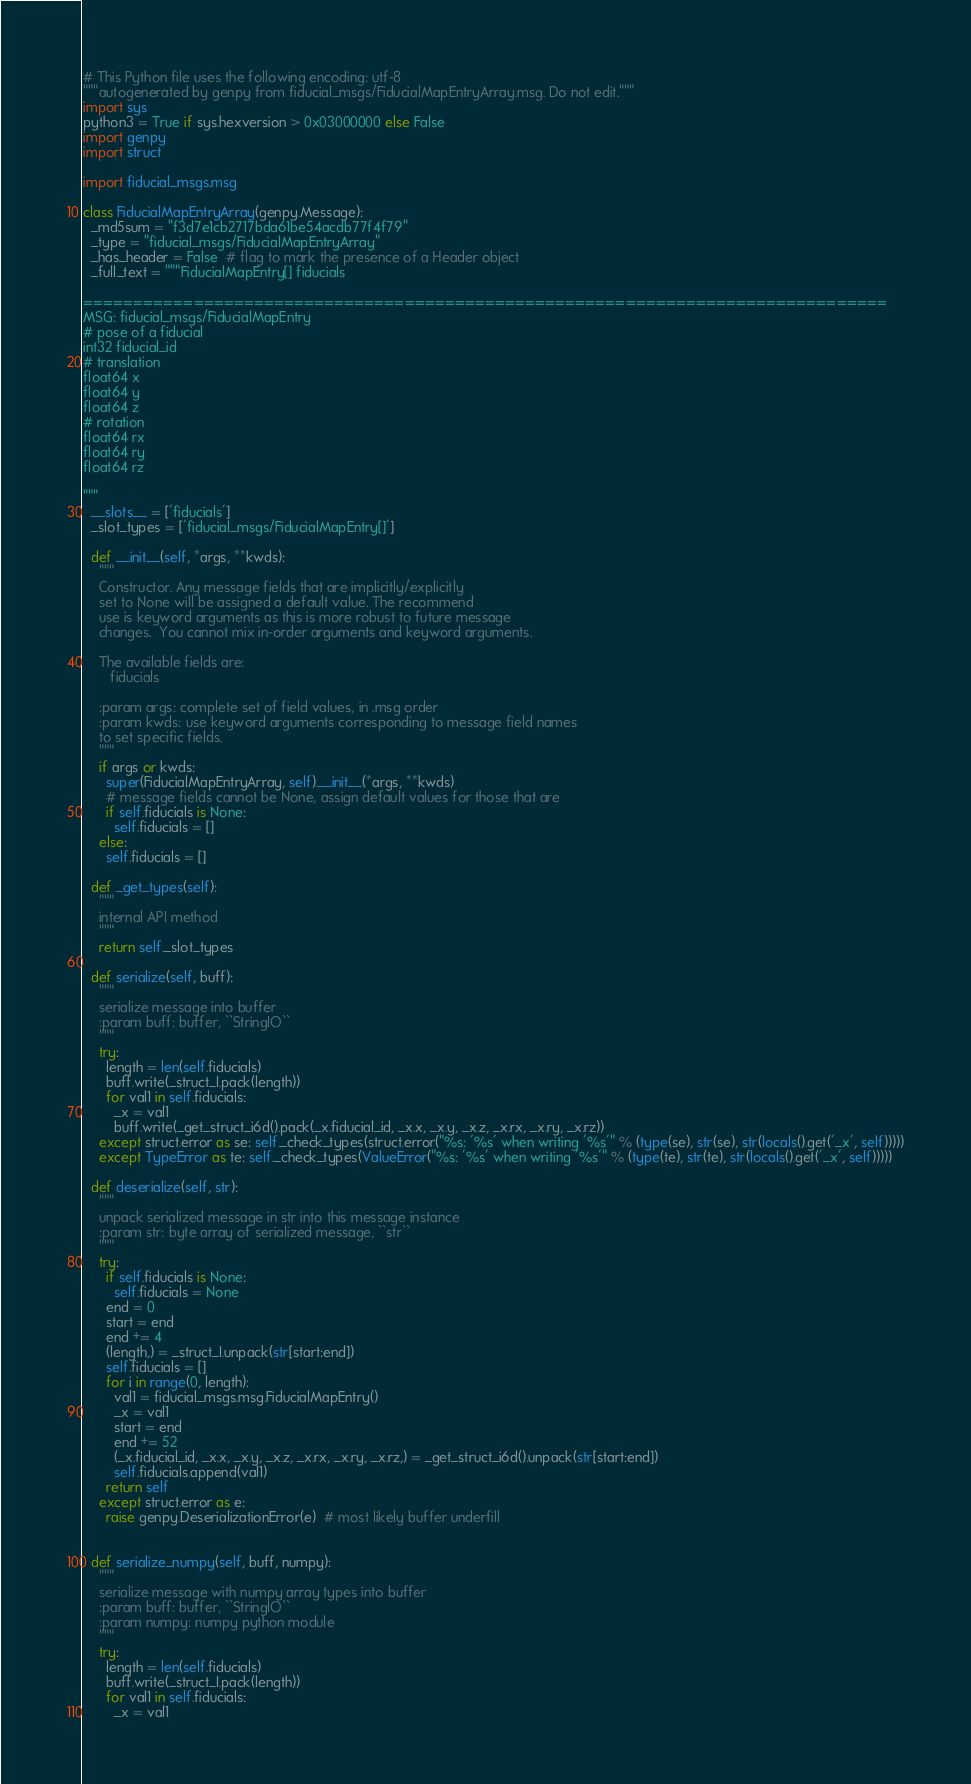<code> <loc_0><loc_0><loc_500><loc_500><_Python_># This Python file uses the following encoding: utf-8
"""autogenerated by genpy from fiducial_msgs/FiducialMapEntryArray.msg. Do not edit."""
import sys
python3 = True if sys.hexversion > 0x03000000 else False
import genpy
import struct

import fiducial_msgs.msg

class FiducialMapEntryArray(genpy.Message):
  _md5sum = "f3d7e1cb2717bda61be54acdb77f4f79"
  _type = "fiducial_msgs/FiducialMapEntryArray"
  _has_header = False  # flag to mark the presence of a Header object
  _full_text = """FiducialMapEntry[] fiducials

================================================================================
MSG: fiducial_msgs/FiducialMapEntry
# pose of a fiducial
int32 fiducial_id
# translation
float64 x
float64 y
float64 z
# rotation
float64 rx
float64 ry
float64 rz

"""
  __slots__ = ['fiducials']
  _slot_types = ['fiducial_msgs/FiducialMapEntry[]']

  def __init__(self, *args, **kwds):
    """
    Constructor. Any message fields that are implicitly/explicitly
    set to None will be assigned a default value. The recommend
    use is keyword arguments as this is more robust to future message
    changes.  You cannot mix in-order arguments and keyword arguments.

    The available fields are:
       fiducials

    :param args: complete set of field values, in .msg order
    :param kwds: use keyword arguments corresponding to message field names
    to set specific fields.
    """
    if args or kwds:
      super(FiducialMapEntryArray, self).__init__(*args, **kwds)
      # message fields cannot be None, assign default values for those that are
      if self.fiducials is None:
        self.fiducials = []
    else:
      self.fiducials = []

  def _get_types(self):
    """
    internal API method
    """
    return self._slot_types

  def serialize(self, buff):
    """
    serialize message into buffer
    :param buff: buffer, ``StringIO``
    """
    try:
      length = len(self.fiducials)
      buff.write(_struct_I.pack(length))
      for val1 in self.fiducials:
        _x = val1
        buff.write(_get_struct_i6d().pack(_x.fiducial_id, _x.x, _x.y, _x.z, _x.rx, _x.ry, _x.rz))
    except struct.error as se: self._check_types(struct.error("%s: '%s' when writing '%s'" % (type(se), str(se), str(locals().get('_x', self)))))
    except TypeError as te: self._check_types(ValueError("%s: '%s' when writing '%s'" % (type(te), str(te), str(locals().get('_x', self)))))

  def deserialize(self, str):
    """
    unpack serialized message in str into this message instance
    :param str: byte array of serialized message, ``str``
    """
    try:
      if self.fiducials is None:
        self.fiducials = None
      end = 0
      start = end
      end += 4
      (length,) = _struct_I.unpack(str[start:end])
      self.fiducials = []
      for i in range(0, length):
        val1 = fiducial_msgs.msg.FiducialMapEntry()
        _x = val1
        start = end
        end += 52
        (_x.fiducial_id, _x.x, _x.y, _x.z, _x.rx, _x.ry, _x.rz,) = _get_struct_i6d().unpack(str[start:end])
        self.fiducials.append(val1)
      return self
    except struct.error as e:
      raise genpy.DeserializationError(e)  # most likely buffer underfill


  def serialize_numpy(self, buff, numpy):
    """
    serialize message with numpy array types into buffer
    :param buff: buffer, ``StringIO``
    :param numpy: numpy python module
    """
    try:
      length = len(self.fiducials)
      buff.write(_struct_I.pack(length))
      for val1 in self.fiducials:
        _x = val1</code> 